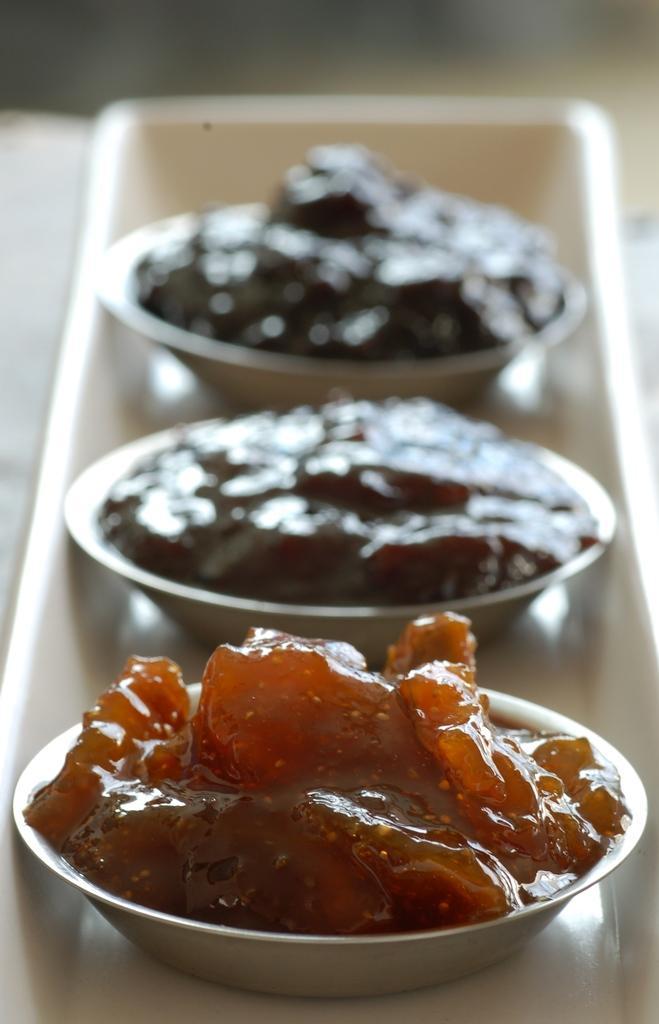In one or two sentences, can you explain what this image depicts? In this image we can see a tray containing three bowls with food placed on the surface. 